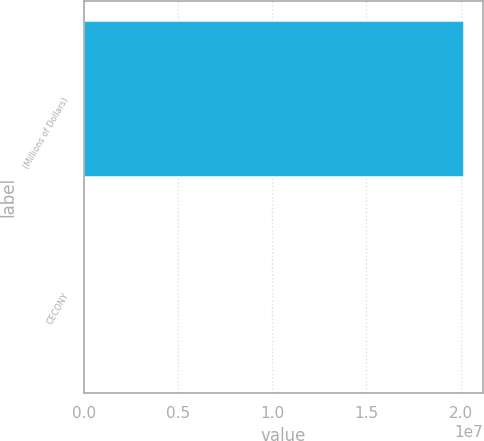Convert chart. <chart><loc_0><loc_0><loc_500><loc_500><bar_chart><fcel>(Millions of Dollars)<fcel>CECONY<nl><fcel>2.0162e+07<fcel>3150<nl></chart> 